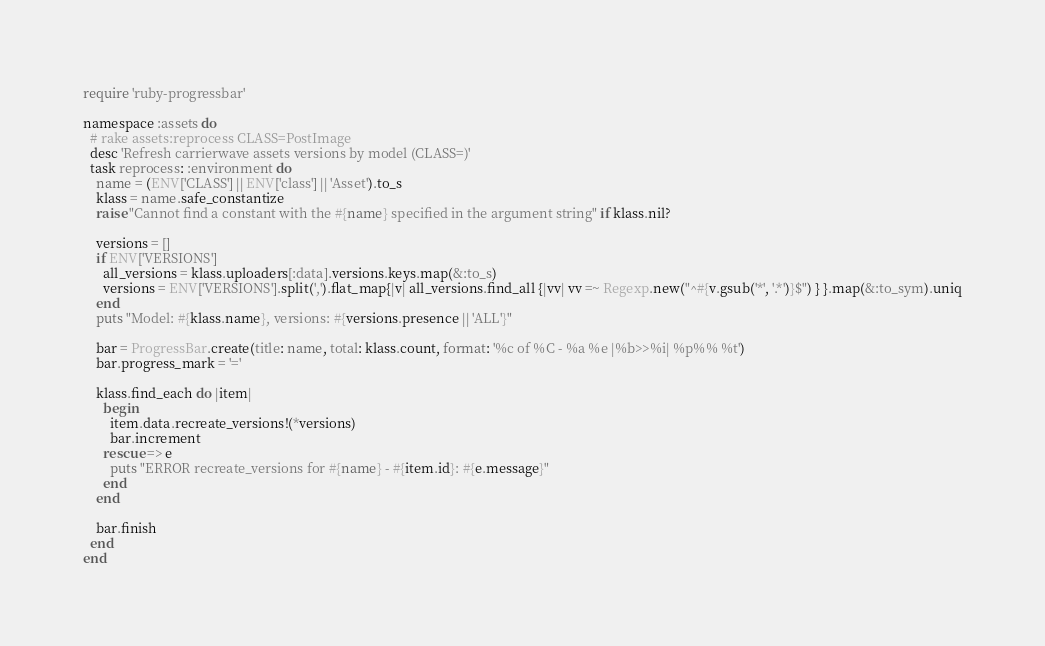<code> <loc_0><loc_0><loc_500><loc_500><_Ruby_>require 'ruby-progressbar'

namespace :assets do
  # rake assets:reprocess CLASS=PostImage
  desc 'Refresh carrierwave assets versions by model (CLASS=)'
  task reprocess: :environment do
    name = (ENV['CLASS'] || ENV['class'] || 'Asset').to_s
    klass = name.safe_constantize
    raise "Cannot find a constant with the #{name} specified in the argument string" if klass.nil?

    versions = []
    if ENV['VERSIONS']
      all_versions = klass.uploaders[:data].versions.keys.map(&:to_s)
      versions = ENV['VERSIONS'].split(',').flat_map{|v| all_versions.find_all {|vv| vv =~ Regexp.new("^#{v.gsub('*', '.*')}$") } }.map(&:to_sym).uniq
    end
    puts "Model: #{klass.name}, versions: #{versions.presence || 'ALL'}"

    bar = ProgressBar.create(title: name, total: klass.count, format: '%c of %C - %a %e |%b>>%i| %p%% %t')
    bar.progress_mark = '='

    klass.find_each do |item|
      begin
        item.data.recreate_versions!(*versions)
        bar.increment
      rescue => e
        puts "ERROR recreate_versions for #{name} - #{item.id}: #{e.message}"
      end
    end

    bar.finish
  end
end
</code> 